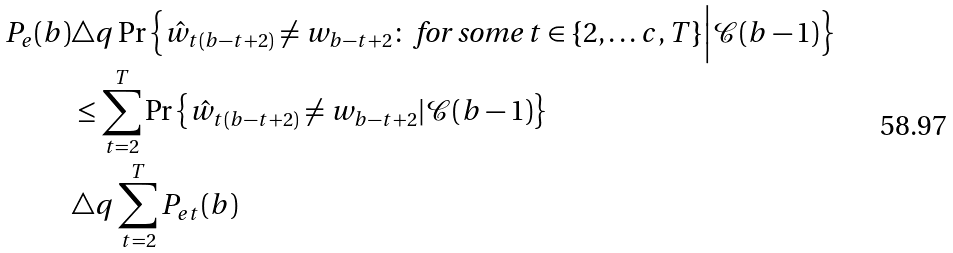Convert formula to latex. <formula><loc_0><loc_0><loc_500><loc_500>P _ { e } ( b ) & \triangle q \Pr \Big \{ \hat { w } _ { t ( b - t + 2 ) } \neq w _ { b - t + 2 } \colon \text { for some } t \in \{ 2 , \dots c , T \} \Big | \mathcal { C } ( b - 1 ) \Big \} \\ & \leq \sum _ { t = 2 } ^ { T } \Pr \left \{ \hat { w } _ { t ( b - t + 2 ) } \neq w _ { b - t + 2 } | \mathcal { C } { ( b - 1 ) } \right \} \\ & \triangle q \sum _ { t = 2 } ^ { T } P _ { e t } ( b )</formula> 